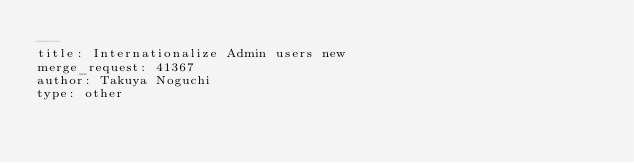Convert code to text. <code><loc_0><loc_0><loc_500><loc_500><_YAML_>---
title: Internationalize Admin users new
merge_request: 41367
author: Takuya Noguchi
type: other
</code> 